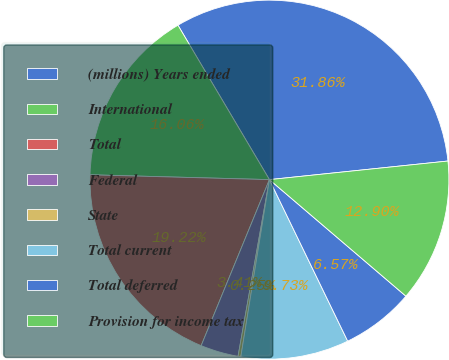Convert chart. <chart><loc_0><loc_0><loc_500><loc_500><pie_chart><fcel>(millions) Years ended<fcel>International<fcel>Total<fcel>Federal<fcel>State<fcel>Total current<fcel>Total deferred<fcel>Provision for income tax<nl><fcel>31.86%<fcel>16.06%<fcel>19.22%<fcel>3.41%<fcel>0.25%<fcel>9.73%<fcel>6.57%<fcel>12.9%<nl></chart> 